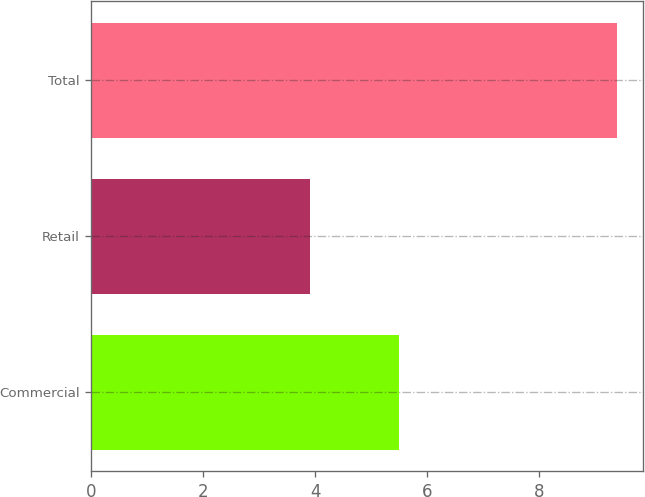<chart> <loc_0><loc_0><loc_500><loc_500><bar_chart><fcel>Commercial<fcel>Retail<fcel>Total<nl><fcel>5.5<fcel>3.9<fcel>9.4<nl></chart> 